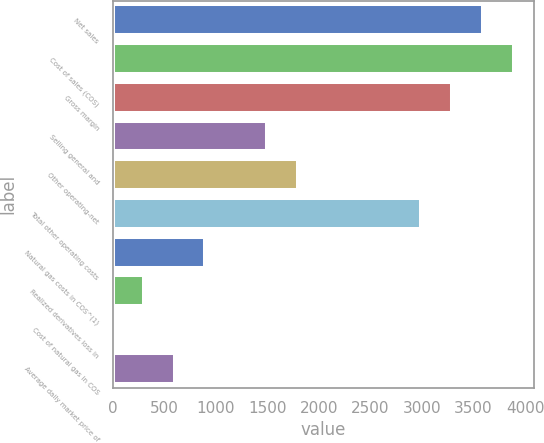Convert chart to OTSL. <chart><loc_0><loc_0><loc_500><loc_500><bar_chart><fcel>Net sales<fcel>Cost of sales (COS)<fcel>Gross margin<fcel>Selling general and<fcel>Other operating-net<fcel>Total other operating costs<fcel>Natural gas costs in COS^(1)<fcel>Realized derivatives loss in<fcel>Cost of natural gas in COS<fcel>Average daily market price of<nl><fcel>3593.97<fcel>3893.44<fcel>3294.5<fcel>1497.68<fcel>1797.15<fcel>2995.03<fcel>898.74<fcel>299.8<fcel>0.33<fcel>599.27<nl></chart> 